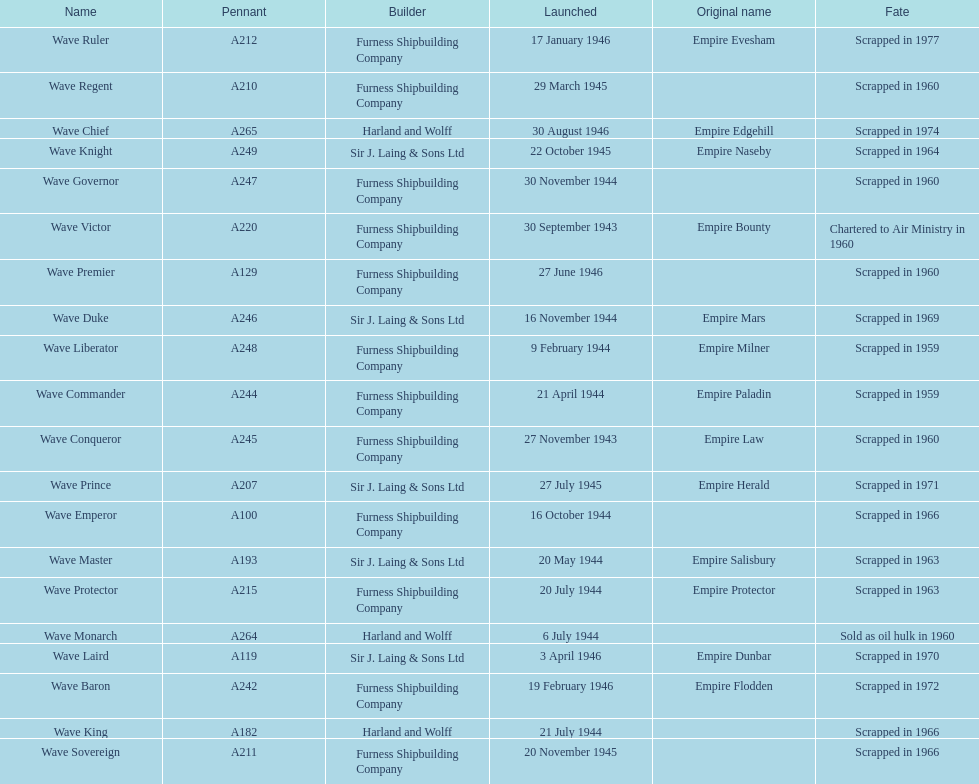Could you parse the entire table as a dict? {'header': ['Name', 'Pennant', 'Builder', 'Launched', 'Original name', 'Fate'], 'rows': [['Wave Ruler', 'A212', 'Furness Shipbuilding Company', '17 January 1946', 'Empire Evesham', 'Scrapped in 1977'], ['Wave Regent', 'A210', 'Furness Shipbuilding Company', '29 March 1945', '', 'Scrapped in 1960'], ['Wave Chief', 'A265', 'Harland and Wolff', '30 August 1946', 'Empire Edgehill', 'Scrapped in 1974'], ['Wave Knight', 'A249', 'Sir J. Laing & Sons Ltd', '22 October 1945', 'Empire Naseby', 'Scrapped in 1964'], ['Wave Governor', 'A247', 'Furness Shipbuilding Company', '30 November 1944', '', 'Scrapped in 1960'], ['Wave Victor', 'A220', 'Furness Shipbuilding Company', '30 September 1943', 'Empire Bounty', 'Chartered to Air Ministry in 1960'], ['Wave Premier', 'A129', 'Furness Shipbuilding Company', '27 June 1946', '', 'Scrapped in 1960'], ['Wave Duke', 'A246', 'Sir J. Laing & Sons Ltd', '16 November 1944', 'Empire Mars', 'Scrapped in 1969'], ['Wave Liberator', 'A248', 'Furness Shipbuilding Company', '9 February 1944', 'Empire Milner', 'Scrapped in 1959'], ['Wave Commander', 'A244', 'Furness Shipbuilding Company', '21 April 1944', 'Empire Paladin', 'Scrapped in 1959'], ['Wave Conqueror', 'A245', 'Furness Shipbuilding Company', '27 November 1943', 'Empire Law', 'Scrapped in 1960'], ['Wave Prince', 'A207', 'Sir J. Laing & Sons Ltd', '27 July 1945', 'Empire Herald', 'Scrapped in 1971'], ['Wave Emperor', 'A100', 'Furness Shipbuilding Company', '16 October 1944', '', 'Scrapped in 1966'], ['Wave Master', 'A193', 'Sir J. Laing & Sons Ltd', '20 May 1944', 'Empire Salisbury', 'Scrapped in 1963'], ['Wave Protector', 'A215', 'Furness Shipbuilding Company', '20 July 1944', 'Empire Protector', 'Scrapped in 1963'], ['Wave Monarch', 'A264', 'Harland and Wolff', '6 July 1944', '', 'Sold as oil hulk in 1960'], ['Wave Laird', 'A119', 'Sir J. Laing & Sons Ltd', '3 April 1946', 'Empire Dunbar', 'Scrapped in 1970'], ['Wave Baron', 'A242', 'Furness Shipbuilding Company', '19 February 1946', 'Empire Flodden', 'Scrapped in 1972'], ['Wave King', 'A182', 'Harland and Wolff', '21 July 1944', '', 'Scrapped in 1966'], ['Wave Sovereign', 'A211', 'Furness Shipbuilding Company', '20 November 1945', '', 'Scrapped in 1966']]} What was the next wave class oiler after wave emperor? Wave Duke. 